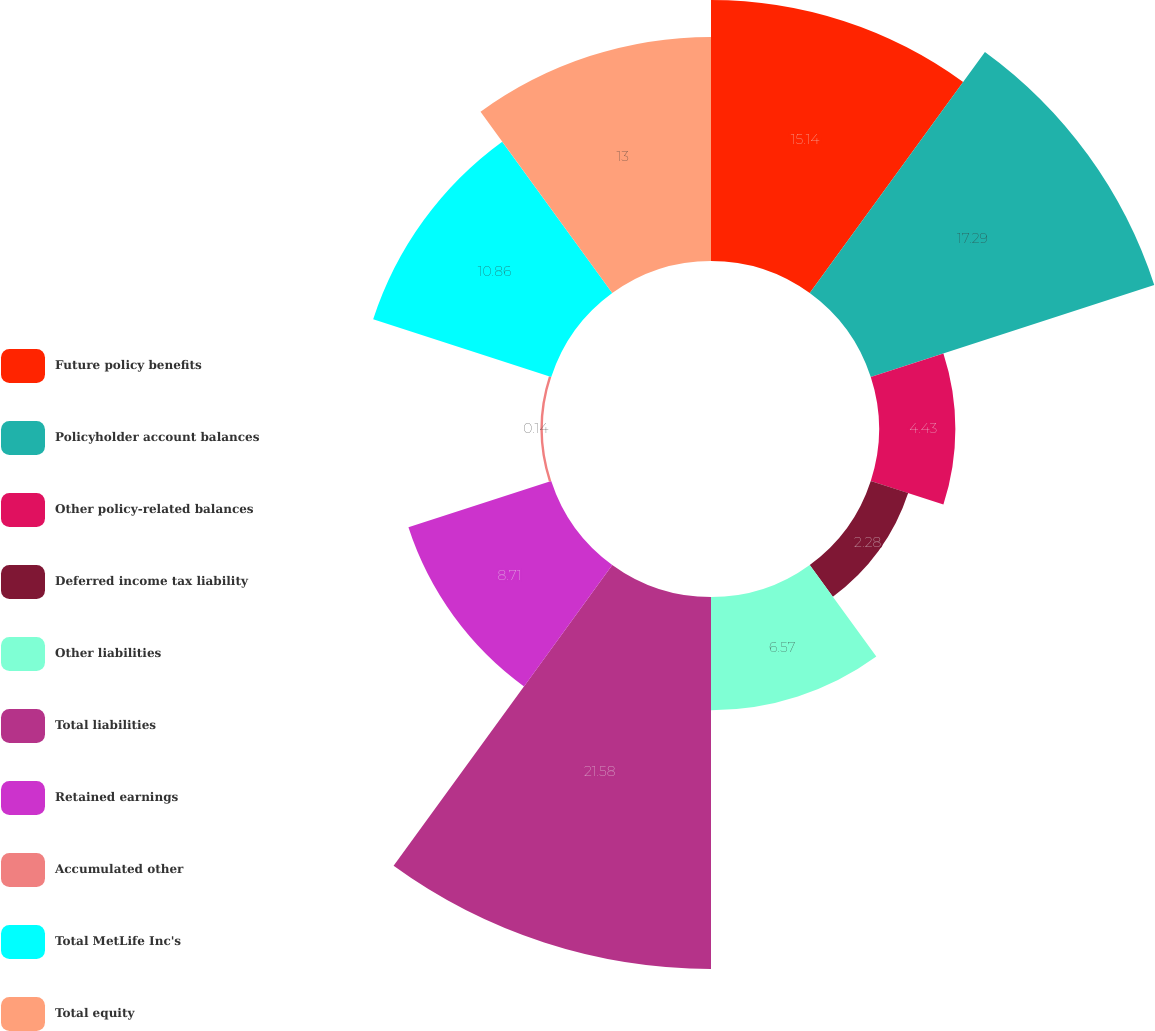Convert chart. <chart><loc_0><loc_0><loc_500><loc_500><pie_chart><fcel>Future policy benefits<fcel>Policyholder account balances<fcel>Other policy-related balances<fcel>Deferred income tax liability<fcel>Other liabilities<fcel>Total liabilities<fcel>Retained earnings<fcel>Accumulated other<fcel>Total MetLife Inc's<fcel>Total equity<nl><fcel>15.14%<fcel>17.29%<fcel>4.43%<fcel>2.28%<fcel>6.57%<fcel>21.58%<fcel>8.71%<fcel>0.14%<fcel>10.86%<fcel>13.0%<nl></chart> 